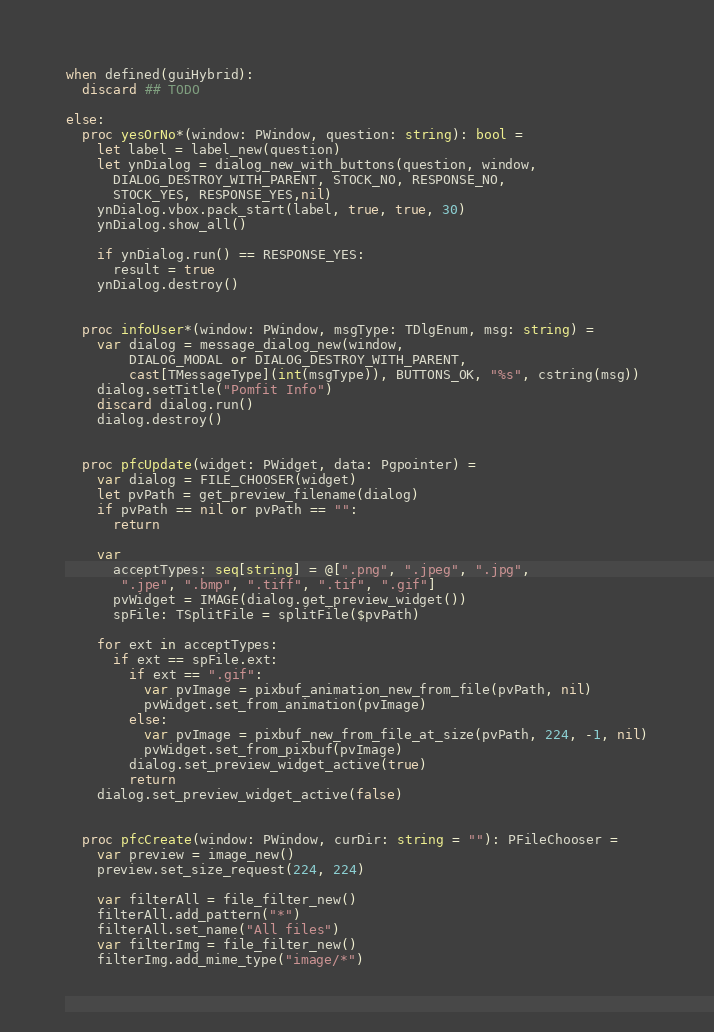<code> <loc_0><loc_0><loc_500><loc_500><_Nim_>when defined(guiHybrid):
  discard ## TODO

else:
  proc yesOrNo*(window: PWindow, question: string): bool =
    let label = label_new(question)
    let ynDialog = dialog_new_with_buttons(question, window,
      DIALOG_DESTROY_WITH_PARENT, STOCK_NO, RESPONSE_NO,
      STOCK_YES, RESPONSE_YES,nil)
    ynDialog.vbox.pack_start(label, true, true, 30)
    ynDialog.show_all()

    if ynDialog.run() == RESPONSE_YES:
      result = true
    ynDialog.destroy()


  proc infoUser*(window: PWindow, msgType: TDlgEnum, msg: string) =
    var dialog = message_dialog_new(window,
        DIALOG_MODAL or DIALOG_DESTROY_WITH_PARENT,
        cast[TMessageType](int(msgType)), BUTTONS_OK, "%s", cstring(msg))
    dialog.setTitle("Pomfit Info")
    discard dialog.run()
    dialog.destroy()
  
  
  proc pfcUpdate(widget: PWidget, data: Pgpointer) =
    var dialog = FILE_CHOOSER(widget)
    let pvPath = get_preview_filename(dialog)
    if pvPath == nil or pvPath == "":
      return
    
    var
      acceptTypes: seq[string] = @[".png", ".jpeg", ".jpg",
       ".jpe", ".bmp", ".tiff", ".tif", ".gif"]
      pvWidget = IMAGE(dialog.get_preview_widget())
      spFile: TSplitFile = splitFile($pvPath)
    
    for ext in acceptTypes:
      if ext == spFile.ext:
        if ext == ".gif":
          var pvImage = pixbuf_animation_new_from_file(pvPath, nil)
          pvWidget.set_from_animation(pvImage)
        else:
          var pvImage = pixbuf_new_from_file_at_size(pvPath, 224, -1, nil)
          pvWidget.set_from_pixbuf(pvImage)
        dialog.set_preview_widget_active(true)
        return
    dialog.set_preview_widget_active(false)
  
  
  proc pfcCreate(window: PWindow, curDir: string = ""): PFileChooser =
    var preview = image_new()
    preview.set_size_request(224, 224)

    var filterAll = file_filter_new()
    filterAll.add_pattern("*")
    filterAll.set_name("All files")
    var filterImg = file_filter_new()
    filterImg.add_mime_type("image/*")</code> 